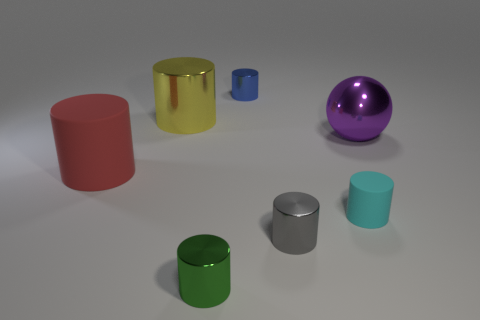Do the yellow shiny thing and the big purple shiny object have the same shape?
Provide a succinct answer. No. What is the size of the green shiny thing that is the same shape as the tiny gray shiny object?
Keep it short and to the point. Small. What shape is the matte object that is right of the rubber object that is left of the yellow object?
Offer a terse response. Cylinder. How big is the gray cylinder?
Provide a succinct answer. Small. What is the shape of the large rubber thing?
Provide a short and direct response. Cylinder. There is a blue metal thing; does it have the same shape as the object that is right of the small matte thing?
Make the answer very short. No. There is a tiny shiny thing that is left of the small blue shiny thing; is its shape the same as the tiny gray object?
Ensure brevity in your answer.  Yes. How many metal cylinders are behind the big purple metal sphere and in front of the small cyan matte thing?
Offer a very short reply. 0. What number of other objects are there of the same size as the cyan rubber cylinder?
Keep it short and to the point. 3. Are there the same number of purple metal balls that are to the left of the green object and tiny red metal spheres?
Keep it short and to the point. Yes. 